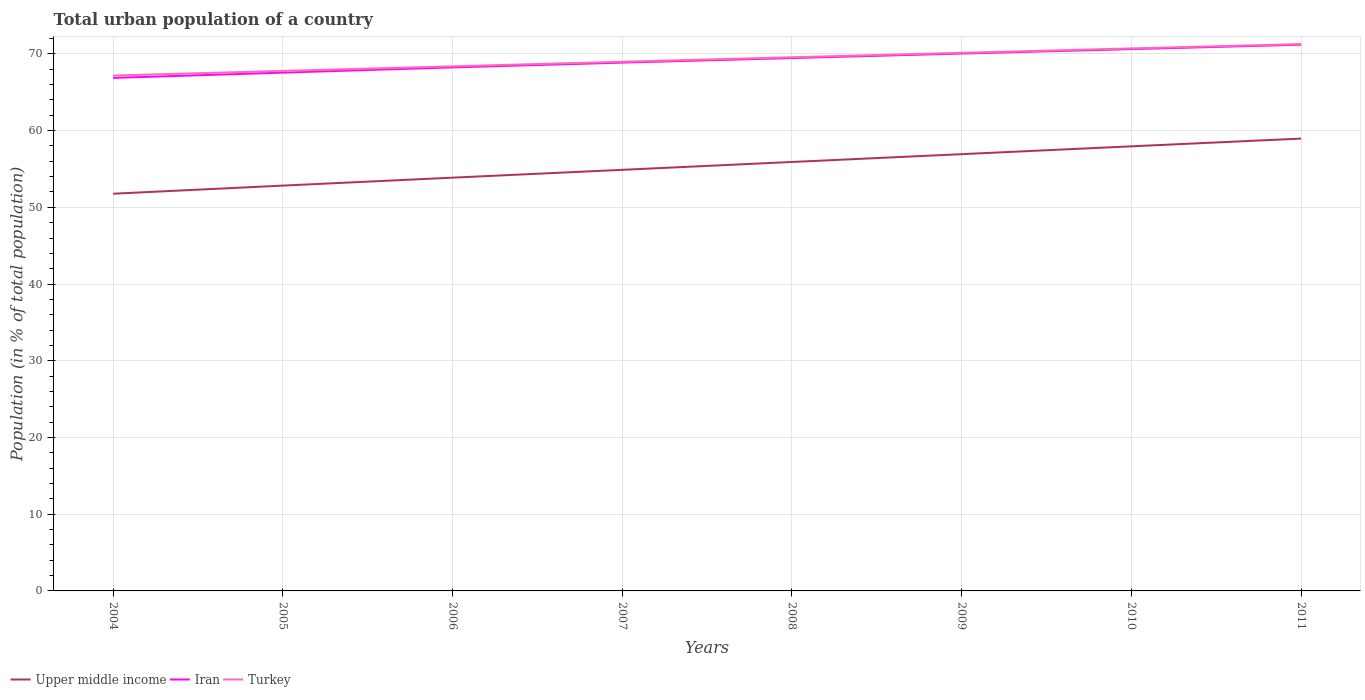Does the line corresponding to Iran intersect with the line corresponding to Turkey?
Your answer should be very brief. No. Is the number of lines equal to the number of legend labels?
Keep it short and to the point. Yes. Across all years, what is the maximum urban population in Turkey?
Your answer should be very brief. 67.18. What is the total urban population in Iran in the graph?
Provide a succinct answer. -4.33. What is the difference between the highest and the second highest urban population in Upper middle income?
Offer a terse response. 7.19. How many lines are there?
Your response must be concise. 3. How many years are there in the graph?
Your answer should be compact. 8. What is the difference between two consecutive major ticks on the Y-axis?
Give a very brief answer. 10. Are the values on the major ticks of Y-axis written in scientific E-notation?
Keep it short and to the point. No. Does the graph contain grids?
Make the answer very short. Yes. Where does the legend appear in the graph?
Provide a succinct answer. Bottom left. How are the legend labels stacked?
Your response must be concise. Horizontal. What is the title of the graph?
Keep it short and to the point. Total urban population of a country. What is the label or title of the X-axis?
Offer a terse response. Years. What is the label or title of the Y-axis?
Provide a succinct answer. Population (in % of total population). What is the Population (in % of total population) in Upper middle income in 2004?
Provide a succinct answer. 51.77. What is the Population (in % of total population) of Iran in 2004?
Offer a very short reply. 66.87. What is the Population (in % of total population) in Turkey in 2004?
Offer a terse response. 67.18. What is the Population (in % of total population) of Upper middle income in 2005?
Your answer should be compact. 52.83. What is the Population (in % of total population) of Iran in 2005?
Your answer should be very brief. 67.56. What is the Population (in % of total population) of Turkey in 2005?
Offer a terse response. 67.78. What is the Population (in % of total population) of Upper middle income in 2006?
Make the answer very short. 53.87. What is the Population (in % of total population) in Iran in 2006?
Your answer should be compact. 68.24. What is the Population (in % of total population) of Turkey in 2006?
Give a very brief answer. 68.38. What is the Population (in % of total population) of Upper middle income in 2007?
Provide a succinct answer. 54.89. What is the Population (in % of total population) of Iran in 2007?
Offer a very short reply. 68.86. What is the Population (in % of total population) of Turkey in 2007?
Offer a very short reply. 68.97. What is the Population (in % of total population) in Upper middle income in 2008?
Your response must be concise. 55.91. What is the Population (in % of total population) of Iran in 2008?
Your answer should be very brief. 69.46. What is the Population (in % of total population) in Turkey in 2008?
Offer a very short reply. 69.56. What is the Population (in % of total population) of Upper middle income in 2009?
Provide a short and direct response. 56.93. What is the Population (in % of total population) in Iran in 2009?
Make the answer very short. 70.05. What is the Population (in % of total population) in Turkey in 2009?
Give a very brief answer. 70.14. What is the Population (in % of total population) of Upper middle income in 2010?
Offer a very short reply. 57.95. What is the Population (in % of total population) in Iran in 2010?
Keep it short and to the point. 70.63. What is the Population (in % of total population) in Turkey in 2010?
Give a very brief answer. 70.72. What is the Population (in % of total population) in Upper middle income in 2011?
Provide a succinct answer. 58.96. What is the Population (in % of total population) in Iran in 2011?
Your answer should be compact. 71.2. What is the Population (in % of total population) of Turkey in 2011?
Ensure brevity in your answer.  71.28. Across all years, what is the maximum Population (in % of total population) of Upper middle income?
Your answer should be compact. 58.96. Across all years, what is the maximum Population (in % of total population) of Iran?
Make the answer very short. 71.2. Across all years, what is the maximum Population (in % of total population) in Turkey?
Your response must be concise. 71.28. Across all years, what is the minimum Population (in % of total population) of Upper middle income?
Keep it short and to the point. 51.77. Across all years, what is the minimum Population (in % of total population) of Iran?
Offer a terse response. 66.87. Across all years, what is the minimum Population (in % of total population) in Turkey?
Your answer should be compact. 67.18. What is the total Population (in % of total population) of Upper middle income in the graph?
Provide a succinct answer. 443.12. What is the total Population (in % of total population) in Iran in the graph?
Offer a terse response. 552.86. What is the total Population (in % of total population) in Turkey in the graph?
Provide a short and direct response. 554.02. What is the difference between the Population (in % of total population) of Upper middle income in 2004 and that in 2005?
Offer a very short reply. -1.06. What is the difference between the Population (in % of total population) of Iran in 2004 and that in 2005?
Provide a succinct answer. -0.69. What is the difference between the Population (in % of total population) of Turkey in 2004 and that in 2005?
Your answer should be compact. -0.6. What is the difference between the Population (in % of total population) in Upper middle income in 2004 and that in 2006?
Make the answer very short. -2.09. What is the difference between the Population (in % of total population) of Iran in 2004 and that in 2006?
Your answer should be very brief. -1.37. What is the difference between the Population (in % of total population) in Turkey in 2004 and that in 2006?
Your response must be concise. -1.2. What is the difference between the Population (in % of total population) of Upper middle income in 2004 and that in 2007?
Offer a very short reply. -3.11. What is the difference between the Population (in % of total population) in Iran in 2004 and that in 2007?
Provide a succinct answer. -2. What is the difference between the Population (in % of total population) of Turkey in 2004 and that in 2007?
Your answer should be very brief. -1.79. What is the difference between the Population (in % of total population) of Upper middle income in 2004 and that in 2008?
Offer a very short reply. -4.14. What is the difference between the Population (in % of total population) of Iran in 2004 and that in 2008?
Offer a very short reply. -2.59. What is the difference between the Population (in % of total population) of Turkey in 2004 and that in 2008?
Your answer should be compact. -2.38. What is the difference between the Population (in % of total population) in Upper middle income in 2004 and that in 2009?
Offer a terse response. -5.16. What is the difference between the Population (in % of total population) in Iran in 2004 and that in 2009?
Offer a terse response. -3.18. What is the difference between the Population (in % of total population) of Turkey in 2004 and that in 2009?
Ensure brevity in your answer.  -2.96. What is the difference between the Population (in % of total population) in Upper middle income in 2004 and that in 2010?
Provide a short and direct response. -6.18. What is the difference between the Population (in % of total population) in Iran in 2004 and that in 2010?
Provide a succinct answer. -3.76. What is the difference between the Population (in % of total population) of Turkey in 2004 and that in 2010?
Ensure brevity in your answer.  -3.54. What is the difference between the Population (in % of total population) of Upper middle income in 2004 and that in 2011?
Offer a very short reply. -7.19. What is the difference between the Population (in % of total population) of Iran in 2004 and that in 2011?
Give a very brief answer. -4.33. What is the difference between the Population (in % of total population) of Turkey in 2004 and that in 2011?
Provide a short and direct response. -4.1. What is the difference between the Population (in % of total population) of Upper middle income in 2005 and that in 2006?
Provide a succinct answer. -1.04. What is the difference between the Population (in % of total population) of Iran in 2005 and that in 2006?
Give a very brief answer. -0.68. What is the difference between the Population (in % of total population) in Turkey in 2005 and that in 2006?
Keep it short and to the point. -0.6. What is the difference between the Population (in % of total population) of Upper middle income in 2005 and that in 2007?
Offer a terse response. -2.06. What is the difference between the Population (in % of total population) in Iran in 2005 and that in 2007?
Your response must be concise. -1.31. What is the difference between the Population (in % of total population) of Turkey in 2005 and that in 2007?
Keep it short and to the point. -1.19. What is the difference between the Population (in % of total population) of Upper middle income in 2005 and that in 2008?
Offer a terse response. -3.08. What is the difference between the Population (in % of total population) in Iran in 2005 and that in 2008?
Provide a succinct answer. -1.9. What is the difference between the Population (in % of total population) in Turkey in 2005 and that in 2008?
Offer a very short reply. -1.78. What is the difference between the Population (in % of total population) of Upper middle income in 2005 and that in 2009?
Provide a succinct answer. -4.1. What is the difference between the Population (in % of total population) of Iran in 2005 and that in 2009?
Give a very brief answer. -2.49. What is the difference between the Population (in % of total population) of Turkey in 2005 and that in 2009?
Offer a very short reply. -2.36. What is the difference between the Population (in % of total population) of Upper middle income in 2005 and that in 2010?
Provide a short and direct response. -5.12. What is the difference between the Population (in % of total population) in Iran in 2005 and that in 2010?
Give a very brief answer. -3.07. What is the difference between the Population (in % of total population) in Turkey in 2005 and that in 2010?
Your response must be concise. -2.93. What is the difference between the Population (in % of total population) of Upper middle income in 2005 and that in 2011?
Provide a succinct answer. -6.13. What is the difference between the Population (in % of total population) of Iran in 2005 and that in 2011?
Your answer should be compact. -3.64. What is the difference between the Population (in % of total population) in Turkey in 2005 and that in 2011?
Make the answer very short. -3.5. What is the difference between the Population (in % of total population) in Upper middle income in 2006 and that in 2007?
Ensure brevity in your answer.  -1.02. What is the difference between the Population (in % of total population) in Iran in 2006 and that in 2007?
Keep it short and to the point. -0.62. What is the difference between the Population (in % of total population) in Turkey in 2006 and that in 2007?
Your response must be concise. -0.59. What is the difference between the Population (in % of total population) in Upper middle income in 2006 and that in 2008?
Provide a short and direct response. -2.04. What is the difference between the Population (in % of total population) in Iran in 2006 and that in 2008?
Offer a terse response. -1.22. What is the difference between the Population (in % of total population) in Turkey in 2006 and that in 2008?
Ensure brevity in your answer.  -1.18. What is the difference between the Population (in % of total population) of Upper middle income in 2006 and that in 2009?
Give a very brief answer. -3.06. What is the difference between the Population (in % of total population) in Iran in 2006 and that in 2009?
Your answer should be compact. -1.81. What is the difference between the Population (in % of total population) in Turkey in 2006 and that in 2009?
Give a very brief answer. -1.76. What is the difference between the Population (in % of total population) in Upper middle income in 2006 and that in 2010?
Make the answer very short. -4.08. What is the difference between the Population (in % of total population) of Iran in 2006 and that in 2010?
Provide a short and direct response. -2.39. What is the difference between the Population (in % of total population) of Turkey in 2006 and that in 2010?
Offer a terse response. -2.33. What is the difference between the Population (in % of total population) of Upper middle income in 2006 and that in 2011?
Your answer should be very brief. -5.09. What is the difference between the Population (in % of total population) of Iran in 2006 and that in 2011?
Your response must be concise. -2.96. What is the difference between the Population (in % of total population) of Turkey in 2006 and that in 2011?
Give a very brief answer. -2.9. What is the difference between the Population (in % of total population) in Upper middle income in 2007 and that in 2008?
Provide a short and direct response. -1.02. What is the difference between the Population (in % of total population) in Iran in 2007 and that in 2008?
Your answer should be very brief. -0.59. What is the difference between the Population (in % of total population) of Turkey in 2007 and that in 2008?
Your answer should be very brief. -0.59. What is the difference between the Population (in % of total population) of Upper middle income in 2007 and that in 2009?
Give a very brief answer. -2.04. What is the difference between the Population (in % of total population) in Iran in 2007 and that in 2009?
Your answer should be compact. -1.18. What is the difference between the Population (in % of total population) of Turkey in 2007 and that in 2009?
Provide a succinct answer. -1.17. What is the difference between the Population (in % of total population) of Upper middle income in 2007 and that in 2010?
Your answer should be very brief. -3.06. What is the difference between the Population (in % of total population) in Iran in 2007 and that in 2010?
Offer a terse response. -1.76. What is the difference between the Population (in % of total population) of Turkey in 2007 and that in 2010?
Your response must be concise. -1.74. What is the difference between the Population (in % of total population) of Upper middle income in 2007 and that in 2011?
Give a very brief answer. -4.07. What is the difference between the Population (in % of total population) in Iran in 2007 and that in 2011?
Your answer should be very brief. -2.34. What is the difference between the Population (in % of total population) in Turkey in 2007 and that in 2011?
Offer a very short reply. -2.31. What is the difference between the Population (in % of total population) in Upper middle income in 2008 and that in 2009?
Provide a succinct answer. -1.02. What is the difference between the Population (in % of total population) of Iran in 2008 and that in 2009?
Provide a short and direct response. -0.59. What is the difference between the Population (in % of total population) of Turkey in 2008 and that in 2009?
Keep it short and to the point. -0.58. What is the difference between the Population (in % of total population) in Upper middle income in 2008 and that in 2010?
Your answer should be compact. -2.04. What is the difference between the Population (in % of total population) in Iran in 2008 and that in 2010?
Provide a short and direct response. -1.17. What is the difference between the Population (in % of total population) in Turkey in 2008 and that in 2010?
Keep it short and to the point. -1.15. What is the difference between the Population (in % of total population) of Upper middle income in 2008 and that in 2011?
Your answer should be compact. -3.05. What is the difference between the Population (in % of total population) in Iran in 2008 and that in 2011?
Offer a very short reply. -1.74. What is the difference between the Population (in % of total population) in Turkey in 2008 and that in 2011?
Keep it short and to the point. -1.72. What is the difference between the Population (in % of total population) in Upper middle income in 2009 and that in 2010?
Keep it short and to the point. -1.02. What is the difference between the Population (in % of total population) of Iran in 2009 and that in 2010?
Keep it short and to the point. -0.58. What is the difference between the Population (in % of total population) of Turkey in 2009 and that in 2010?
Keep it short and to the point. -0.57. What is the difference between the Population (in % of total population) in Upper middle income in 2009 and that in 2011?
Your answer should be very brief. -2.03. What is the difference between the Population (in % of total population) of Iran in 2009 and that in 2011?
Offer a terse response. -1.16. What is the difference between the Population (in % of total population) of Turkey in 2009 and that in 2011?
Keep it short and to the point. -1.14. What is the difference between the Population (in % of total population) in Upper middle income in 2010 and that in 2011?
Keep it short and to the point. -1.01. What is the difference between the Population (in % of total population) of Iran in 2010 and that in 2011?
Your response must be concise. -0.57. What is the difference between the Population (in % of total population) of Turkey in 2010 and that in 2011?
Provide a succinct answer. -0.57. What is the difference between the Population (in % of total population) in Upper middle income in 2004 and the Population (in % of total population) in Iran in 2005?
Provide a short and direct response. -15.78. What is the difference between the Population (in % of total population) of Upper middle income in 2004 and the Population (in % of total population) of Turkey in 2005?
Your answer should be compact. -16.01. What is the difference between the Population (in % of total population) of Iran in 2004 and the Population (in % of total population) of Turkey in 2005?
Ensure brevity in your answer.  -0.91. What is the difference between the Population (in % of total population) of Upper middle income in 2004 and the Population (in % of total population) of Iran in 2006?
Make the answer very short. -16.46. What is the difference between the Population (in % of total population) of Upper middle income in 2004 and the Population (in % of total population) of Turkey in 2006?
Your answer should be compact. -16.61. What is the difference between the Population (in % of total population) in Iran in 2004 and the Population (in % of total population) in Turkey in 2006?
Offer a terse response. -1.51. What is the difference between the Population (in % of total population) of Upper middle income in 2004 and the Population (in % of total population) of Iran in 2007?
Your response must be concise. -17.09. What is the difference between the Population (in % of total population) in Upper middle income in 2004 and the Population (in % of total population) in Turkey in 2007?
Your response must be concise. -17.2. What is the difference between the Population (in % of total population) of Iran in 2004 and the Population (in % of total population) of Turkey in 2007?
Provide a short and direct response. -2.11. What is the difference between the Population (in % of total population) in Upper middle income in 2004 and the Population (in % of total population) in Iran in 2008?
Make the answer very short. -17.68. What is the difference between the Population (in % of total population) of Upper middle income in 2004 and the Population (in % of total population) of Turkey in 2008?
Your answer should be very brief. -17.79. What is the difference between the Population (in % of total population) of Iran in 2004 and the Population (in % of total population) of Turkey in 2008?
Your response must be concise. -2.69. What is the difference between the Population (in % of total population) in Upper middle income in 2004 and the Population (in % of total population) in Iran in 2009?
Your answer should be compact. -18.27. What is the difference between the Population (in % of total population) of Upper middle income in 2004 and the Population (in % of total population) of Turkey in 2009?
Keep it short and to the point. -18.37. What is the difference between the Population (in % of total population) in Iran in 2004 and the Population (in % of total population) in Turkey in 2009?
Give a very brief answer. -3.27. What is the difference between the Population (in % of total population) of Upper middle income in 2004 and the Population (in % of total population) of Iran in 2010?
Keep it short and to the point. -18.85. What is the difference between the Population (in % of total population) of Upper middle income in 2004 and the Population (in % of total population) of Turkey in 2010?
Keep it short and to the point. -18.94. What is the difference between the Population (in % of total population) of Iran in 2004 and the Population (in % of total population) of Turkey in 2010?
Keep it short and to the point. -3.85. What is the difference between the Population (in % of total population) of Upper middle income in 2004 and the Population (in % of total population) of Iran in 2011?
Your response must be concise. -19.43. What is the difference between the Population (in % of total population) in Upper middle income in 2004 and the Population (in % of total population) in Turkey in 2011?
Your answer should be very brief. -19.51. What is the difference between the Population (in % of total population) of Iran in 2004 and the Population (in % of total population) of Turkey in 2011?
Keep it short and to the point. -4.41. What is the difference between the Population (in % of total population) in Upper middle income in 2005 and the Population (in % of total population) in Iran in 2006?
Provide a succinct answer. -15.41. What is the difference between the Population (in % of total population) in Upper middle income in 2005 and the Population (in % of total population) in Turkey in 2006?
Give a very brief answer. -15.55. What is the difference between the Population (in % of total population) in Iran in 2005 and the Population (in % of total population) in Turkey in 2006?
Keep it short and to the point. -0.82. What is the difference between the Population (in % of total population) of Upper middle income in 2005 and the Population (in % of total population) of Iran in 2007?
Your answer should be very brief. -16.03. What is the difference between the Population (in % of total population) of Upper middle income in 2005 and the Population (in % of total population) of Turkey in 2007?
Provide a succinct answer. -16.14. What is the difference between the Population (in % of total population) in Iran in 2005 and the Population (in % of total population) in Turkey in 2007?
Provide a succinct answer. -1.42. What is the difference between the Population (in % of total population) of Upper middle income in 2005 and the Population (in % of total population) of Iran in 2008?
Keep it short and to the point. -16.63. What is the difference between the Population (in % of total population) of Upper middle income in 2005 and the Population (in % of total population) of Turkey in 2008?
Give a very brief answer. -16.73. What is the difference between the Population (in % of total population) in Iran in 2005 and the Population (in % of total population) in Turkey in 2008?
Ensure brevity in your answer.  -2. What is the difference between the Population (in % of total population) in Upper middle income in 2005 and the Population (in % of total population) in Iran in 2009?
Your response must be concise. -17.21. What is the difference between the Population (in % of total population) of Upper middle income in 2005 and the Population (in % of total population) of Turkey in 2009?
Offer a very short reply. -17.31. What is the difference between the Population (in % of total population) of Iran in 2005 and the Population (in % of total population) of Turkey in 2009?
Your answer should be very brief. -2.58. What is the difference between the Population (in % of total population) in Upper middle income in 2005 and the Population (in % of total population) in Iran in 2010?
Your response must be concise. -17.79. What is the difference between the Population (in % of total population) of Upper middle income in 2005 and the Population (in % of total population) of Turkey in 2010?
Provide a short and direct response. -17.88. What is the difference between the Population (in % of total population) in Iran in 2005 and the Population (in % of total population) in Turkey in 2010?
Make the answer very short. -3.16. What is the difference between the Population (in % of total population) of Upper middle income in 2005 and the Population (in % of total population) of Iran in 2011?
Offer a very short reply. -18.37. What is the difference between the Population (in % of total population) of Upper middle income in 2005 and the Population (in % of total population) of Turkey in 2011?
Give a very brief answer. -18.45. What is the difference between the Population (in % of total population) of Iran in 2005 and the Population (in % of total population) of Turkey in 2011?
Your response must be concise. -3.72. What is the difference between the Population (in % of total population) in Upper middle income in 2006 and the Population (in % of total population) in Iran in 2007?
Provide a succinct answer. -15. What is the difference between the Population (in % of total population) in Upper middle income in 2006 and the Population (in % of total population) in Turkey in 2007?
Ensure brevity in your answer.  -15.11. What is the difference between the Population (in % of total population) in Iran in 2006 and the Population (in % of total population) in Turkey in 2007?
Your answer should be compact. -0.74. What is the difference between the Population (in % of total population) in Upper middle income in 2006 and the Population (in % of total population) in Iran in 2008?
Ensure brevity in your answer.  -15.59. What is the difference between the Population (in % of total population) in Upper middle income in 2006 and the Population (in % of total population) in Turkey in 2008?
Make the answer very short. -15.69. What is the difference between the Population (in % of total population) in Iran in 2006 and the Population (in % of total population) in Turkey in 2008?
Provide a succinct answer. -1.32. What is the difference between the Population (in % of total population) of Upper middle income in 2006 and the Population (in % of total population) of Iran in 2009?
Offer a terse response. -16.18. What is the difference between the Population (in % of total population) of Upper middle income in 2006 and the Population (in % of total population) of Turkey in 2009?
Provide a short and direct response. -16.27. What is the difference between the Population (in % of total population) of Iran in 2006 and the Population (in % of total population) of Turkey in 2009?
Make the answer very short. -1.9. What is the difference between the Population (in % of total population) of Upper middle income in 2006 and the Population (in % of total population) of Iran in 2010?
Make the answer very short. -16.76. What is the difference between the Population (in % of total population) in Upper middle income in 2006 and the Population (in % of total population) in Turkey in 2010?
Offer a very short reply. -16.85. What is the difference between the Population (in % of total population) in Iran in 2006 and the Population (in % of total population) in Turkey in 2010?
Make the answer very short. -2.48. What is the difference between the Population (in % of total population) in Upper middle income in 2006 and the Population (in % of total population) in Iran in 2011?
Ensure brevity in your answer.  -17.33. What is the difference between the Population (in % of total population) in Upper middle income in 2006 and the Population (in % of total population) in Turkey in 2011?
Offer a terse response. -17.41. What is the difference between the Population (in % of total population) in Iran in 2006 and the Population (in % of total population) in Turkey in 2011?
Ensure brevity in your answer.  -3.04. What is the difference between the Population (in % of total population) in Upper middle income in 2007 and the Population (in % of total population) in Iran in 2008?
Offer a terse response. -14.57. What is the difference between the Population (in % of total population) of Upper middle income in 2007 and the Population (in % of total population) of Turkey in 2008?
Provide a succinct answer. -14.67. What is the difference between the Population (in % of total population) of Iran in 2007 and the Population (in % of total population) of Turkey in 2008?
Your response must be concise. -0.7. What is the difference between the Population (in % of total population) in Upper middle income in 2007 and the Population (in % of total population) in Iran in 2009?
Offer a very short reply. -15.16. What is the difference between the Population (in % of total population) in Upper middle income in 2007 and the Population (in % of total population) in Turkey in 2009?
Your answer should be very brief. -15.25. What is the difference between the Population (in % of total population) in Iran in 2007 and the Population (in % of total population) in Turkey in 2009?
Give a very brief answer. -1.28. What is the difference between the Population (in % of total population) in Upper middle income in 2007 and the Population (in % of total population) in Iran in 2010?
Give a very brief answer. -15.74. What is the difference between the Population (in % of total population) of Upper middle income in 2007 and the Population (in % of total population) of Turkey in 2010?
Ensure brevity in your answer.  -15.83. What is the difference between the Population (in % of total population) of Iran in 2007 and the Population (in % of total population) of Turkey in 2010?
Your answer should be compact. -1.85. What is the difference between the Population (in % of total population) of Upper middle income in 2007 and the Population (in % of total population) of Iran in 2011?
Your response must be concise. -16.31. What is the difference between the Population (in % of total population) of Upper middle income in 2007 and the Population (in % of total population) of Turkey in 2011?
Give a very brief answer. -16.39. What is the difference between the Population (in % of total population) in Iran in 2007 and the Population (in % of total population) in Turkey in 2011?
Give a very brief answer. -2.42. What is the difference between the Population (in % of total population) in Upper middle income in 2008 and the Population (in % of total population) in Iran in 2009?
Provide a succinct answer. -14.13. What is the difference between the Population (in % of total population) of Upper middle income in 2008 and the Population (in % of total population) of Turkey in 2009?
Your response must be concise. -14.23. What is the difference between the Population (in % of total population) of Iran in 2008 and the Population (in % of total population) of Turkey in 2009?
Your answer should be very brief. -0.68. What is the difference between the Population (in % of total population) in Upper middle income in 2008 and the Population (in % of total population) in Iran in 2010?
Give a very brief answer. -14.71. What is the difference between the Population (in % of total population) of Upper middle income in 2008 and the Population (in % of total population) of Turkey in 2010?
Ensure brevity in your answer.  -14.8. What is the difference between the Population (in % of total population) of Iran in 2008 and the Population (in % of total population) of Turkey in 2010?
Your answer should be very brief. -1.26. What is the difference between the Population (in % of total population) of Upper middle income in 2008 and the Population (in % of total population) of Iran in 2011?
Your answer should be very brief. -15.29. What is the difference between the Population (in % of total population) in Upper middle income in 2008 and the Population (in % of total population) in Turkey in 2011?
Ensure brevity in your answer.  -15.37. What is the difference between the Population (in % of total population) in Iran in 2008 and the Population (in % of total population) in Turkey in 2011?
Offer a very short reply. -1.82. What is the difference between the Population (in % of total population) in Upper middle income in 2009 and the Population (in % of total population) in Iran in 2010?
Give a very brief answer. -13.7. What is the difference between the Population (in % of total population) of Upper middle income in 2009 and the Population (in % of total population) of Turkey in 2010?
Keep it short and to the point. -13.78. What is the difference between the Population (in % of total population) of Iran in 2009 and the Population (in % of total population) of Turkey in 2010?
Give a very brief answer. -0.67. What is the difference between the Population (in % of total population) of Upper middle income in 2009 and the Population (in % of total population) of Iran in 2011?
Provide a succinct answer. -14.27. What is the difference between the Population (in % of total population) of Upper middle income in 2009 and the Population (in % of total population) of Turkey in 2011?
Offer a terse response. -14.35. What is the difference between the Population (in % of total population) of Iran in 2009 and the Population (in % of total population) of Turkey in 2011?
Offer a terse response. -1.24. What is the difference between the Population (in % of total population) in Upper middle income in 2010 and the Population (in % of total population) in Iran in 2011?
Your answer should be very brief. -13.25. What is the difference between the Population (in % of total population) in Upper middle income in 2010 and the Population (in % of total population) in Turkey in 2011?
Offer a terse response. -13.33. What is the difference between the Population (in % of total population) of Iran in 2010 and the Population (in % of total population) of Turkey in 2011?
Your answer should be compact. -0.66. What is the average Population (in % of total population) of Upper middle income per year?
Provide a succinct answer. 55.39. What is the average Population (in % of total population) of Iran per year?
Give a very brief answer. 69.11. What is the average Population (in % of total population) of Turkey per year?
Your response must be concise. 69.25. In the year 2004, what is the difference between the Population (in % of total population) in Upper middle income and Population (in % of total population) in Iran?
Provide a succinct answer. -15.1. In the year 2004, what is the difference between the Population (in % of total population) of Upper middle income and Population (in % of total population) of Turkey?
Your answer should be very brief. -15.41. In the year 2004, what is the difference between the Population (in % of total population) of Iran and Population (in % of total population) of Turkey?
Ensure brevity in your answer.  -0.31. In the year 2005, what is the difference between the Population (in % of total population) in Upper middle income and Population (in % of total population) in Iran?
Ensure brevity in your answer.  -14.73. In the year 2005, what is the difference between the Population (in % of total population) of Upper middle income and Population (in % of total population) of Turkey?
Offer a terse response. -14.95. In the year 2005, what is the difference between the Population (in % of total population) in Iran and Population (in % of total population) in Turkey?
Offer a very short reply. -0.23. In the year 2006, what is the difference between the Population (in % of total population) in Upper middle income and Population (in % of total population) in Iran?
Provide a succinct answer. -14.37. In the year 2006, what is the difference between the Population (in % of total population) in Upper middle income and Population (in % of total population) in Turkey?
Your response must be concise. -14.51. In the year 2006, what is the difference between the Population (in % of total population) in Iran and Population (in % of total population) in Turkey?
Make the answer very short. -0.14. In the year 2007, what is the difference between the Population (in % of total population) of Upper middle income and Population (in % of total population) of Iran?
Offer a terse response. -13.98. In the year 2007, what is the difference between the Population (in % of total population) in Upper middle income and Population (in % of total population) in Turkey?
Provide a short and direct response. -14.09. In the year 2007, what is the difference between the Population (in % of total population) of Iran and Population (in % of total population) of Turkey?
Provide a short and direct response. -0.11. In the year 2008, what is the difference between the Population (in % of total population) of Upper middle income and Population (in % of total population) of Iran?
Provide a succinct answer. -13.55. In the year 2008, what is the difference between the Population (in % of total population) of Upper middle income and Population (in % of total population) of Turkey?
Give a very brief answer. -13.65. In the year 2008, what is the difference between the Population (in % of total population) in Iran and Population (in % of total population) in Turkey?
Your response must be concise. -0.1. In the year 2009, what is the difference between the Population (in % of total population) of Upper middle income and Population (in % of total population) of Iran?
Give a very brief answer. -13.11. In the year 2009, what is the difference between the Population (in % of total population) in Upper middle income and Population (in % of total population) in Turkey?
Offer a very short reply. -13.21. In the year 2009, what is the difference between the Population (in % of total population) of Iran and Population (in % of total population) of Turkey?
Offer a terse response. -0.1. In the year 2010, what is the difference between the Population (in % of total population) of Upper middle income and Population (in % of total population) of Iran?
Ensure brevity in your answer.  -12.68. In the year 2010, what is the difference between the Population (in % of total population) of Upper middle income and Population (in % of total population) of Turkey?
Your response must be concise. -12.76. In the year 2010, what is the difference between the Population (in % of total population) in Iran and Population (in % of total population) in Turkey?
Make the answer very short. -0.09. In the year 2011, what is the difference between the Population (in % of total population) in Upper middle income and Population (in % of total population) in Iran?
Ensure brevity in your answer.  -12.24. In the year 2011, what is the difference between the Population (in % of total population) in Upper middle income and Population (in % of total population) in Turkey?
Offer a terse response. -12.32. In the year 2011, what is the difference between the Population (in % of total population) of Iran and Population (in % of total population) of Turkey?
Make the answer very short. -0.08. What is the ratio of the Population (in % of total population) of Iran in 2004 to that in 2005?
Make the answer very short. 0.99. What is the ratio of the Population (in % of total population) in Turkey in 2004 to that in 2005?
Give a very brief answer. 0.99. What is the ratio of the Population (in % of total population) in Upper middle income in 2004 to that in 2006?
Offer a very short reply. 0.96. What is the ratio of the Population (in % of total population) in Iran in 2004 to that in 2006?
Provide a succinct answer. 0.98. What is the ratio of the Population (in % of total population) of Turkey in 2004 to that in 2006?
Make the answer very short. 0.98. What is the ratio of the Population (in % of total population) in Upper middle income in 2004 to that in 2007?
Your answer should be compact. 0.94. What is the ratio of the Population (in % of total population) in Iran in 2004 to that in 2007?
Make the answer very short. 0.97. What is the ratio of the Population (in % of total population) in Turkey in 2004 to that in 2007?
Your response must be concise. 0.97. What is the ratio of the Population (in % of total population) of Upper middle income in 2004 to that in 2008?
Keep it short and to the point. 0.93. What is the ratio of the Population (in % of total population) of Iran in 2004 to that in 2008?
Make the answer very short. 0.96. What is the ratio of the Population (in % of total population) in Turkey in 2004 to that in 2008?
Make the answer very short. 0.97. What is the ratio of the Population (in % of total population) of Upper middle income in 2004 to that in 2009?
Provide a short and direct response. 0.91. What is the ratio of the Population (in % of total population) in Iran in 2004 to that in 2009?
Give a very brief answer. 0.95. What is the ratio of the Population (in % of total population) of Turkey in 2004 to that in 2009?
Your answer should be compact. 0.96. What is the ratio of the Population (in % of total population) of Upper middle income in 2004 to that in 2010?
Provide a short and direct response. 0.89. What is the ratio of the Population (in % of total population) of Iran in 2004 to that in 2010?
Give a very brief answer. 0.95. What is the ratio of the Population (in % of total population) in Upper middle income in 2004 to that in 2011?
Keep it short and to the point. 0.88. What is the ratio of the Population (in % of total population) in Iran in 2004 to that in 2011?
Your answer should be compact. 0.94. What is the ratio of the Population (in % of total population) in Turkey in 2004 to that in 2011?
Offer a terse response. 0.94. What is the ratio of the Population (in % of total population) of Upper middle income in 2005 to that in 2006?
Give a very brief answer. 0.98. What is the ratio of the Population (in % of total population) of Upper middle income in 2005 to that in 2007?
Make the answer very short. 0.96. What is the ratio of the Population (in % of total population) in Turkey in 2005 to that in 2007?
Offer a very short reply. 0.98. What is the ratio of the Population (in % of total population) of Upper middle income in 2005 to that in 2008?
Provide a short and direct response. 0.94. What is the ratio of the Population (in % of total population) in Iran in 2005 to that in 2008?
Your response must be concise. 0.97. What is the ratio of the Population (in % of total population) in Turkey in 2005 to that in 2008?
Make the answer very short. 0.97. What is the ratio of the Population (in % of total population) in Upper middle income in 2005 to that in 2009?
Offer a very short reply. 0.93. What is the ratio of the Population (in % of total population) in Iran in 2005 to that in 2009?
Your answer should be very brief. 0.96. What is the ratio of the Population (in % of total population) in Turkey in 2005 to that in 2009?
Your response must be concise. 0.97. What is the ratio of the Population (in % of total population) in Upper middle income in 2005 to that in 2010?
Provide a short and direct response. 0.91. What is the ratio of the Population (in % of total population) of Iran in 2005 to that in 2010?
Provide a succinct answer. 0.96. What is the ratio of the Population (in % of total population) in Turkey in 2005 to that in 2010?
Provide a succinct answer. 0.96. What is the ratio of the Population (in % of total population) in Upper middle income in 2005 to that in 2011?
Provide a short and direct response. 0.9. What is the ratio of the Population (in % of total population) in Iran in 2005 to that in 2011?
Offer a very short reply. 0.95. What is the ratio of the Population (in % of total population) in Turkey in 2005 to that in 2011?
Keep it short and to the point. 0.95. What is the ratio of the Population (in % of total population) in Upper middle income in 2006 to that in 2007?
Your answer should be compact. 0.98. What is the ratio of the Population (in % of total population) of Iran in 2006 to that in 2007?
Provide a short and direct response. 0.99. What is the ratio of the Population (in % of total population) of Turkey in 2006 to that in 2007?
Your answer should be very brief. 0.99. What is the ratio of the Population (in % of total population) in Upper middle income in 2006 to that in 2008?
Ensure brevity in your answer.  0.96. What is the ratio of the Population (in % of total population) in Iran in 2006 to that in 2008?
Your response must be concise. 0.98. What is the ratio of the Population (in % of total population) in Upper middle income in 2006 to that in 2009?
Ensure brevity in your answer.  0.95. What is the ratio of the Population (in % of total population) of Iran in 2006 to that in 2009?
Offer a very short reply. 0.97. What is the ratio of the Population (in % of total population) of Turkey in 2006 to that in 2009?
Provide a succinct answer. 0.97. What is the ratio of the Population (in % of total population) of Upper middle income in 2006 to that in 2010?
Provide a succinct answer. 0.93. What is the ratio of the Population (in % of total population) of Iran in 2006 to that in 2010?
Ensure brevity in your answer.  0.97. What is the ratio of the Population (in % of total population) in Turkey in 2006 to that in 2010?
Your response must be concise. 0.97. What is the ratio of the Population (in % of total population) in Upper middle income in 2006 to that in 2011?
Keep it short and to the point. 0.91. What is the ratio of the Population (in % of total population) in Iran in 2006 to that in 2011?
Provide a short and direct response. 0.96. What is the ratio of the Population (in % of total population) of Turkey in 2006 to that in 2011?
Ensure brevity in your answer.  0.96. What is the ratio of the Population (in % of total population) in Upper middle income in 2007 to that in 2008?
Your answer should be very brief. 0.98. What is the ratio of the Population (in % of total population) in Iran in 2007 to that in 2008?
Your answer should be very brief. 0.99. What is the ratio of the Population (in % of total population) in Upper middle income in 2007 to that in 2009?
Give a very brief answer. 0.96. What is the ratio of the Population (in % of total population) of Iran in 2007 to that in 2009?
Offer a terse response. 0.98. What is the ratio of the Population (in % of total population) of Turkey in 2007 to that in 2009?
Your answer should be compact. 0.98. What is the ratio of the Population (in % of total population) in Upper middle income in 2007 to that in 2010?
Your answer should be very brief. 0.95. What is the ratio of the Population (in % of total population) in Iran in 2007 to that in 2010?
Your answer should be compact. 0.98. What is the ratio of the Population (in % of total population) in Turkey in 2007 to that in 2010?
Offer a very short reply. 0.98. What is the ratio of the Population (in % of total population) of Upper middle income in 2007 to that in 2011?
Provide a succinct answer. 0.93. What is the ratio of the Population (in % of total population) in Iran in 2007 to that in 2011?
Offer a terse response. 0.97. What is the ratio of the Population (in % of total population) of Turkey in 2007 to that in 2011?
Your answer should be very brief. 0.97. What is the ratio of the Population (in % of total population) in Upper middle income in 2008 to that in 2009?
Your response must be concise. 0.98. What is the ratio of the Population (in % of total population) in Upper middle income in 2008 to that in 2010?
Your answer should be compact. 0.96. What is the ratio of the Population (in % of total population) of Iran in 2008 to that in 2010?
Keep it short and to the point. 0.98. What is the ratio of the Population (in % of total population) of Turkey in 2008 to that in 2010?
Keep it short and to the point. 0.98. What is the ratio of the Population (in % of total population) of Upper middle income in 2008 to that in 2011?
Your response must be concise. 0.95. What is the ratio of the Population (in % of total population) of Iran in 2008 to that in 2011?
Give a very brief answer. 0.98. What is the ratio of the Population (in % of total population) in Turkey in 2008 to that in 2011?
Give a very brief answer. 0.98. What is the ratio of the Population (in % of total population) of Upper middle income in 2009 to that in 2010?
Your answer should be compact. 0.98. What is the ratio of the Population (in % of total population) in Iran in 2009 to that in 2010?
Provide a succinct answer. 0.99. What is the ratio of the Population (in % of total population) in Turkey in 2009 to that in 2010?
Offer a terse response. 0.99. What is the ratio of the Population (in % of total population) in Upper middle income in 2009 to that in 2011?
Your answer should be compact. 0.97. What is the ratio of the Population (in % of total population) of Iran in 2009 to that in 2011?
Offer a very short reply. 0.98. What is the ratio of the Population (in % of total population) of Turkey in 2009 to that in 2011?
Provide a succinct answer. 0.98. What is the ratio of the Population (in % of total population) of Upper middle income in 2010 to that in 2011?
Ensure brevity in your answer.  0.98. What is the ratio of the Population (in % of total population) in Turkey in 2010 to that in 2011?
Offer a very short reply. 0.99. What is the difference between the highest and the second highest Population (in % of total population) in Upper middle income?
Give a very brief answer. 1.01. What is the difference between the highest and the second highest Population (in % of total population) of Iran?
Your answer should be compact. 0.57. What is the difference between the highest and the second highest Population (in % of total population) of Turkey?
Offer a terse response. 0.57. What is the difference between the highest and the lowest Population (in % of total population) in Upper middle income?
Provide a succinct answer. 7.19. What is the difference between the highest and the lowest Population (in % of total population) in Iran?
Your answer should be very brief. 4.33. What is the difference between the highest and the lowest Population (in % of total population) in Turkey?
Give a very brief answer. 4.1. 